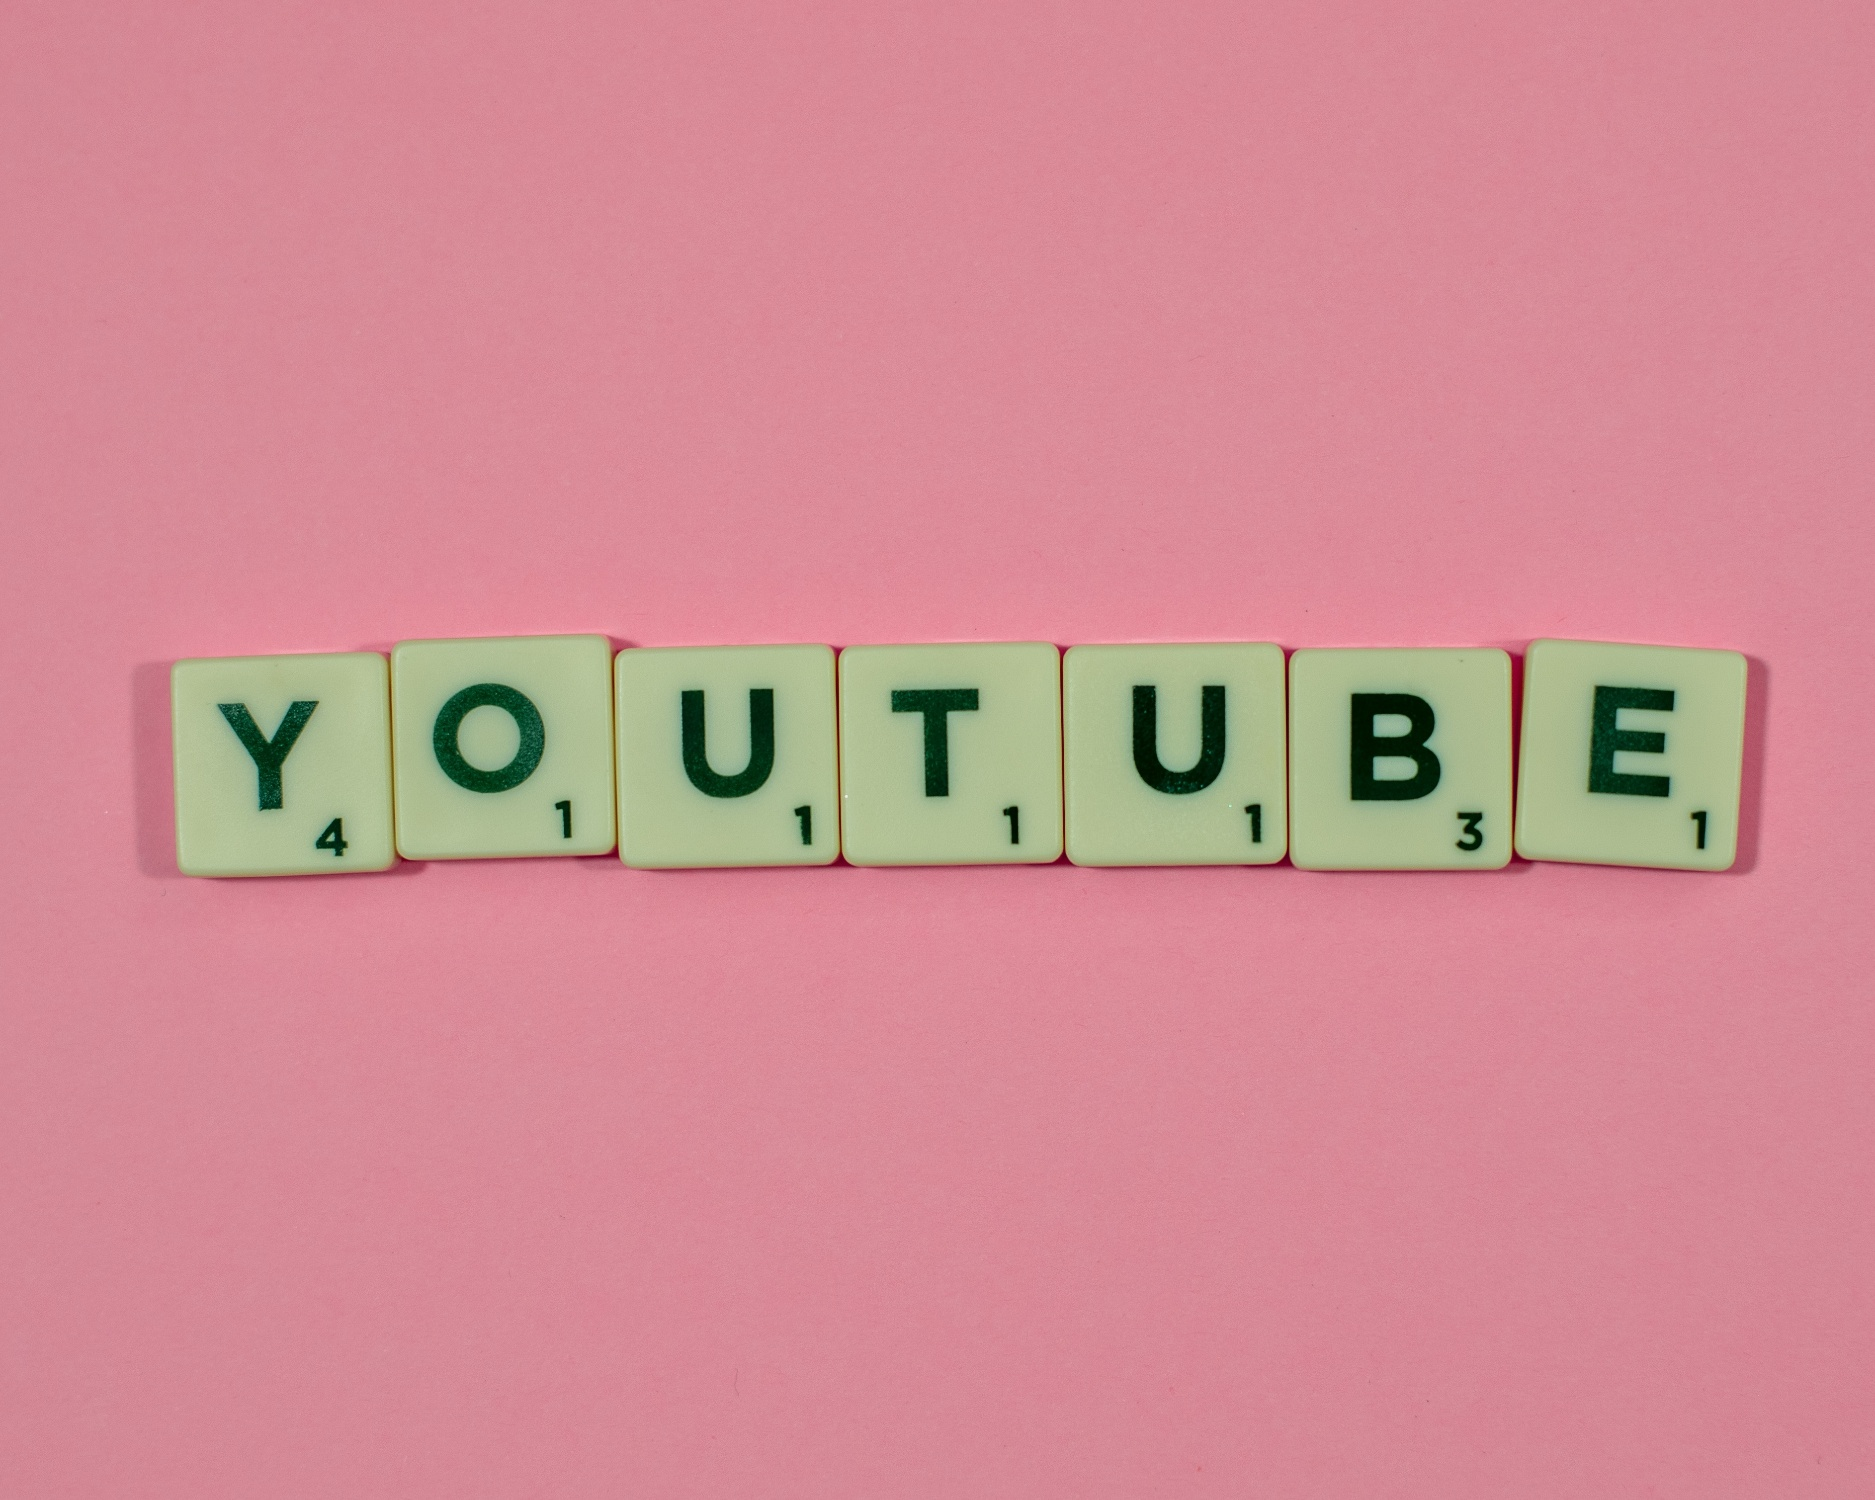If this image were part of an advertisement, what might it be promoting? If this image were part of an advertisement, it could be promoting YouTube or a related service, such as a Scrabble-themed video series on the platform. The colorful and engaging visual would attract attention and communicate the idea of combining fun with the educational aspect of word games. The Scrabble tiles spelling out 'YOUTUBE' create a clear connection to the video-sharing platform, suggesting content that is both entertaining and intellectually stimulating. 